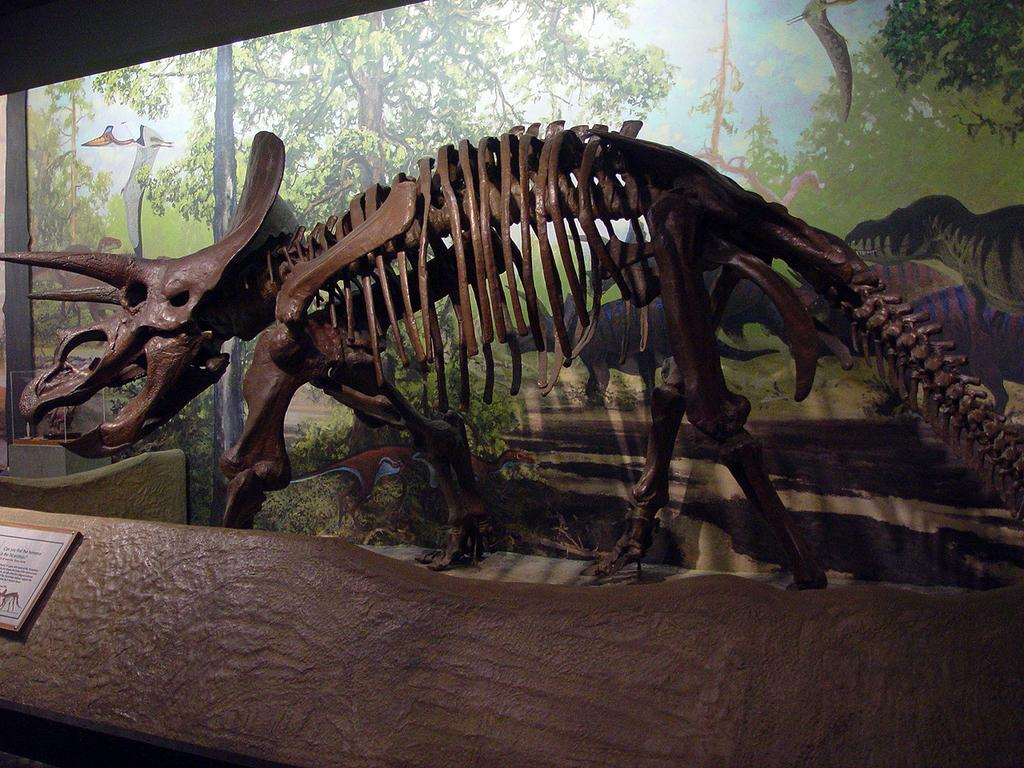What is the main subject in the center of the image? There is a skeleton of a dinosaur in the center of the image. What else can be seen in the background of the image? There is a poster in the background area of the image. What type of watch is the dinosaur wearing in the image? There is no watch visible on the dinosaur in the image, as it is a skeleton and not a living creature. 